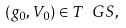<formula> <loc_0><loc_0><loc_500><loc_500>( g _ { 0 } , V _ { 0 } ) \in T \ G S ,</formula> 